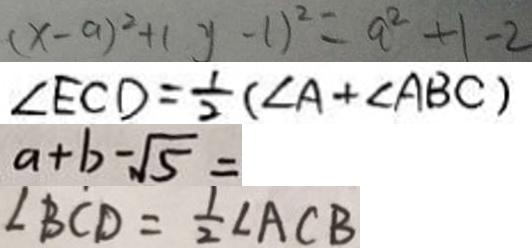Convert formula to latex. <formula><loc_0><loc_0><loc_500><loc_500>( x - a ) ^ { 2 } + ( y - 1 ) ^ { 2 } = a ^ { 2 } + 1 - 2 
 \angle E C D = \frac { 1 } { 2 } ( \angle A + \angle A B C ) 
 a + b - \sqrt { 5 } = 
 \angle B C D = \frac { 1 } { 2 } \angle A C B</formula> 